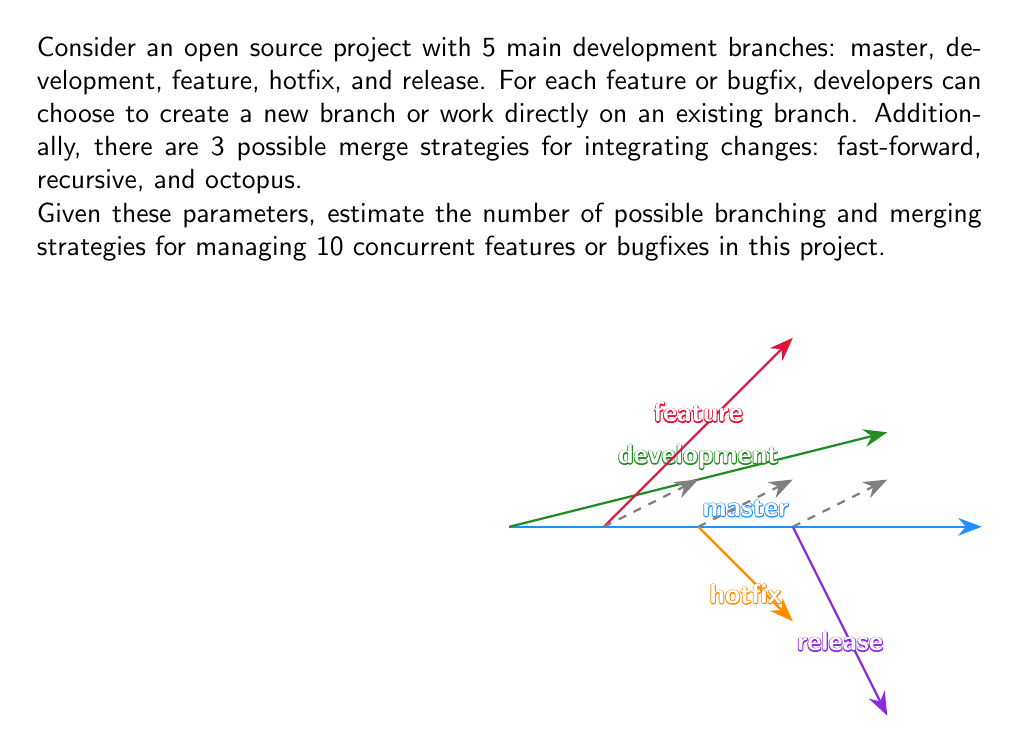Can you answer this question? Let's break this problem down step-by-step:

1) First, we need to consider the branching options for each feature/bugfix:
   - It can be developed on one of the 5 existing branches
   - Or a new branch can be created

   So, there are 6 options for each feature/bugfix.

2) With 10 concurrent features/bugfixes, we have:

   $$6^{10}$$ possible branching combinations

3) Now, for each of these branching strategies, we need to consider the merge strategies. There are 3 merge strategies available.

4) In the worst case, if all 10 features/bugfixes were developed on separate branches, we would need 10 merge operations. However, some may be developed on existing branches, reducing the number of merges needed.

5) To simplify our estimate, let's assume an average case where half of the features/bugfixes (5) require merging.

6) For these 5 merges, we have 3 options each, giving us:

   $$3^5$$ possible merge strategy combinations

7) Combining the branching and merging possibilities, we get:

   $$6^{10} \cdot 3^5$$ total possible strategies

8) Let's calculate this:
   $$6^{10} = 60,466,176$$
   $$3^5 = 243$$
   $$60,466,176 \cdot 243 = 14,693,280,768$$

Therefore, we estimate approximately 14.7 billion possible branching and merging strategies for this scenario.
Answer: $6^{10} \cdot 3^5 \approx 1.47 \times 10^{10}$ 